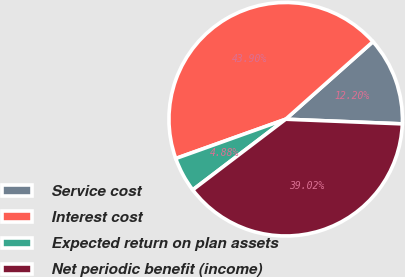Convert chart. <chart><loc_0><loc_0><loc_500><loc_500><pie_chart><fcel>Service cost<fcel>Interest cost<fcel>Expected return on plan assets<fcel>Net periodic benefit (income)<nl><fcel>12.2%<fcel>43.9%<fcel>4.88%<fcel>39.02%<nl></chart> 